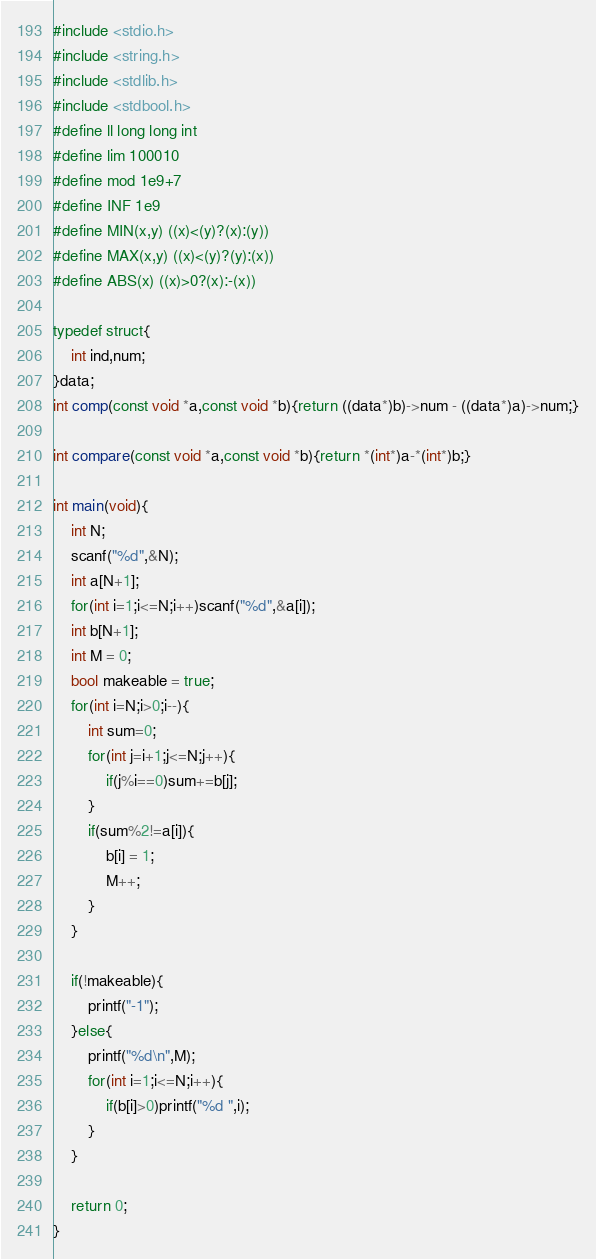<code> <loc_0><loc_0><loc_500><loc_500><_C_>#include <stdio.h>
#include <string.h>
#include <stdlib.h>
#include <stdbool.h>
#define ll long long int
#define lim 100010
#define mod 1e9+7
#define INF 1e9
#define MIN(x,y) ((x)<(y)?(x):(y))
#define MAX(x,y) ((x)<(y)?(y):(x))
#define ABS(x) ((x)>0?(x):-(x))

typedef struct{
	int ind,num;
}data;
int comp(const void *a,const void *b){return ((data*)b)->num - ((data*)a)->num;}

int compare(const void *a,const void *b){return *(int*)a-*(int*)b;}

int main(void){
	int N;
	scanf("%d",&N);
	int a[N+1];
	for(int i=1;i<=N;i++)scanf("%d",&a[i]);
	int b[N+1];
	int M = 0;
	bool makeable = true;
	for(int i=N;i>0;i--){
		int sum=0;
		for(int j=i+1;j<=N;j++){
			if(j%i==0)sum+=b[j];
		}
		if(sum%2!=a[i]){
			b[i] = 1;
			M++;
		}
	}
	
	if(!makeable){
		printf("-1");
	}else{
		printf("%d\n",M);
		for(int i=1;i<=N;i++){
			if(b[i]>0)printf("%d ",i);
		}
	}
	
	return 0;
}</code> 